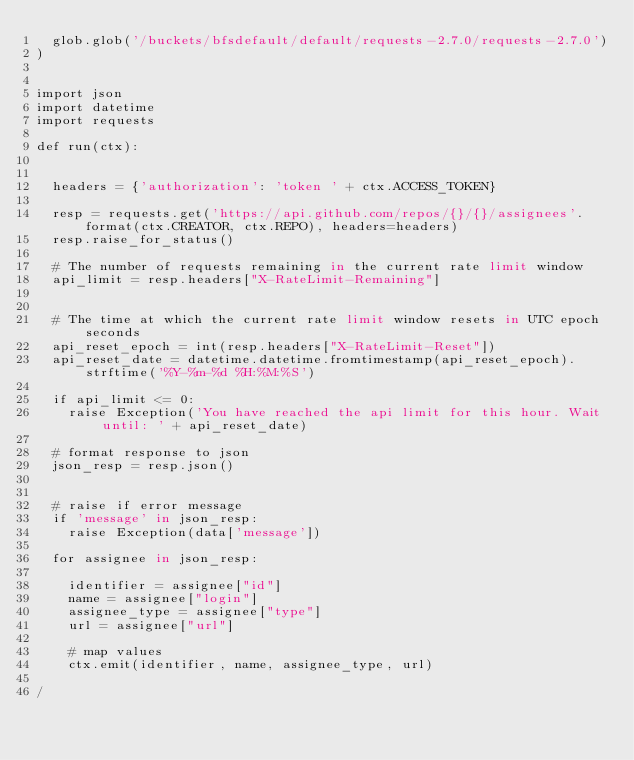<code> <loc_0><loc_0><loc_500><loc_500><_SQL_>	glob.glob('/buckets/bfsdefault/default/requests-2.7.0/requests-2.7.0')
)


import json
import datetime
import requests

def run(ctx):


	headers = {'authorization': 'token ' + ctx.ACCESS_TOKEN}

	resp = requests.get('https://api.github.com/repos/{}/{}/assignees'.format(ctx.CREATOR, ctx.REPO), headers=headers)
	resp.raise_for_status()

	# The number of requests remaining in the current rate limit window
	api_limit = resp.headers["X-RateLimit-Remaining"]


	# The time at which the current rate limit window resets in UTC epoch seconds
	api_reset_epoch = int(resp.headers["X-RateLimit-Reset"])
	api_reset_date = datetime.datetime.fromtimestamp(api_reset_epoch).strftime('%Y-%m-%d %H:%M:%S')

	if api_limit <= 0:
		raise Exception('You have reached the api limit for this hour. Wait until: ' + api_reset_date)

	# format response to json
	json_resp = resp.json()


	# raise if error message
	if 'message' in json_resp:
		raise Exception(data['message'])

	for assignee in json_resp:

		identifier = assignee["id"]
		name = assignee["login"]
		assignee_type = assignee["type"]
		url = assignee["url"]

		# map values
		ctx.emit(identifier, name, assignee_type, url)

/
</code> 